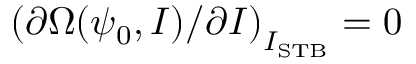<formula> <loc_0><loc_0><loc_500><loc_500>\left ( \partial \Omega ( \psi _ { 0 } , I ) / \partial I \right ) _ { I _ { S T B } } = 0</formula> 